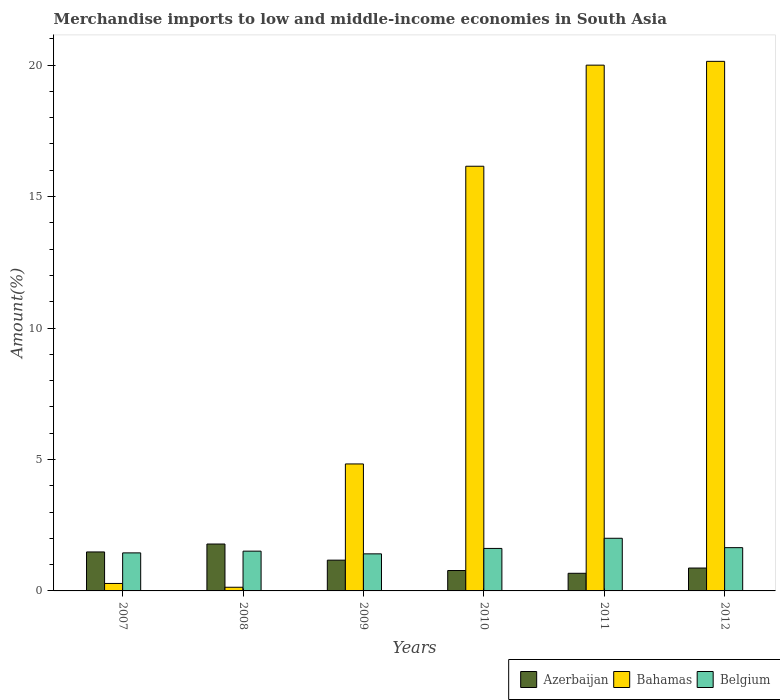How many groups of bars are there?
Offer a terse response. 6. Are the number of bars on each tick of the X-axis equal?
Your answer should be very brief. Yes. How many bars are there on the 4th tick from the left?
Make the answer very short. 3. In how many cases, is the number of bars for a given year not equal to the number of legend labels?
Your answer should be very brief. 0. What is the percentage of amount earned from merchandise imports in Bahamas in 2007?
Give a very brief answer. 0.28. Across all years, what is the maximum percentage of amount earned from merchandise imports in Belgium?
Offer a very short reply. 2. Across all years, what is the minimum percentage of amount earned from merchandise imports in Azerbaijan?
Keep it short and to the point. 0.67. In which year was the percentage of amount earned from merchandise imports in Azerbaijan minimum?
Offer a very short reply. 2011. What is the total percentage of amount earned from merchandise imports in Azerbaijan in the graph?
Your answer should be compact. 6.75. What is the difference between the percentage of amount earned from merchandise imports in Azerbaijan in 2009 and that in 2011?
Provide a succinct answer. 0.5. What is the difference between the percentage of amount earned from merchandise imports in Azerbaijan in 2007 and the percentage of amount earned from merchandise imports in Bahamas in 2010?
Provide a short and direct response. -14.67. What is the average percentage of amount earned from merchandise imports in Bahamas per year?
Keep it short and to the point. 10.26. In the year 2009, what is the difference between the percentage of amount earned from merchandise imports in Belgium and percentage of amount earned from merchandise imports in Bahamas?
Make the answer very short. -3.42. In how many years, is the percentage of amount earned from merchandise imports in Bahamas greater than 11 %?
Offer a terse response. 3. What is the ratio of the percentage of amount earned from merchandise imports in Bahamas in 2009 to that in 2012?
Your response must be concise. 0.24. Is the percentage of amount earned from merchandise imports in Belgium in 2009 less than that in 2010?
Offer a terse response. Yes. What is the difference between the highest and the second highest percentage of amount earned from merchandise imports in Bahamas?
Your response must be concise. 0.14. What is the difference between the highest and the lowest percentage of amount earned from merchandise imports in Azerbaijan?
Ensure brevity in your answer.  1.11. In how many years, is the percentage of amount earned from merchandise imports in Belgium greater than the average percentage of amount earned from merchandise imports in Belgium taken over all years?
Offer a very short reply. 3. Is the sum of the percentage of amount earned from merchandise imports in Bahamas in 2009 and 2012 greater than the maximum percentage of amount earned from merchandise imports in Azerbaijan across all years?
Provide a succinct answer. Yes. What does the 2nd bar from the left in 2010 represents?
Keep it short and to the point. Bahamas. What does the 2nd bar from the right in 2008 represents?
Ensure brevity in your answer.  Bahamas. Is it the case that in every year, the sum of the percentage of amount earned from merchandise imports in Belgium and percentage of amount earned from merchandise imports in Bahamas is greater than the percentage of amount earned from merchandise imports in Azerbaijan?
Keep it short and to the point. No. How many years are there in the graph?
Your answer should be very brief. 6. What is the difference between two consecutive major ticks on the Y-axis?
Your answer should be compact. 5. Are the values on the major ticks of Y-axis written in scientific E-notation?
Provide a succinct answer. No. Does the graph contain any zero values?
Offer a terse response. No. Does the graph contain grids?
Keep it short and to the point. No. Where does the legend appear in the graph?
Offer a terse response. Bottom right. How are the legend labels stacked?
Your answer should be compact. Horizontal. What is the title of the graph?
Offer a very short reply. Merchandise imports to low and middle-income economies in South Asia. Does "Central Europe" appear as one of the legend labels in the graph?
Offer a very short reply. No. What is the label or title of the X-axis?
Your answer should be very brief. Years. What is the label or title of the Y-axis?
Keep it short and to the point. Amount(%). What is the Amount(%) of Azerbaijan in 2007?
Offer a very short reply. 1.48. What is the Amount(%) in Bahamas in 2007?
Provide a succinct answer. 0.28. What is the Amount(%) of Belgium in 2007?
Provide a short and direct response. 1.45. What is the Amount(%) of Azerbaijan in 2008?
Ensure brevity in your answer.  1.78. What is the Amount(%) in Bahamas in 2008?
Your answer should be very brief. 0.14. What is the Amount(%) of Belgium in 2008?
Your response must be concise. 1.51. What is the Amount(%) of Azerbaijan in 2009?
Offer a very short reply. 1.17. What is the Amount(%) of Bahamas in 2009?
Offer a terse response. 4.83. What is the Amount(%) in Belgium in 2009?
Provide a succinct answer. 1.41. What is the Amount(%) of Azerbaijan in 2010?
Ensure brevity in your answer.  0.78. What is the Amount(%) of Bahamas in 2010?
Keep it short and to the point. 16.15. What is the Amount(%) of Belgium in 2010?
Provide a succinct answer. 1.62. What is the Amount(%) of Azerbaijan in 2011?
Your answer should be very brief. 0.67. What is the Amount(%) in Bahamas in 2011?
Your answer should be very brief. 20. What is the Amount(%) in Belgium in 2011?
Offer a very short reply. 2. What is the Amount(%) in Azerbaijan in 2012?
Offer a very short reply. 0.87. What is the Amount(%) in Bahamas in 2012?
Make the answer very short. 20.14. What is the Amount(%) in Belgium in 2012?
Your answer should be compact. 1.65. Across all years, what is the maximum Amount(%) in Azerbaijan?
Keep it short and to the point. 1.78. Across all years, what is the maximum Amount(%) in Bahamas?
Your answer should be compact. 20.14. Across all years, what is the maximum Amount(%) in Belgium?
Ensure brevity in your answer.  2. Across all years, what is the minimum Amount(%) in Azerbaijan?
Make the answer very short. 0.67. Across all years, what is the minimum Amount(%) in Bahamas?
Provide a short and direct response. 0.14. Across all years, what is the minimum Amount(%) in Belgium?
Your answer should be very brief. 1.41. What is the total Amount(%) in Azerbaijan in the graph?
Your answer should be very brief. 6.75. What is the total Amount(%) in Bahamas in the graph?
Give a very brief answer. 61.55. What is the total Amount(%) in Belgium in the graph?
Provide a short and direct response. 9.63. What is the difference between the Amount(%) of Azerbaijan in 2007 and that in 2008?
Your answer should be very brief. -0.3. What is the difference between the Amount(%) in Bahamas in 2007 and that in 2008?
Offer a very short reply. 0.14. What is the difference between the Amount(%) in Belgium in 2007 and that in 2008?
Provide a succinct answer. -0.07. What is the difference between the Amount(%) in Azerbaijan in 2007 and that in 2009?
Ensure brevity in your answer.  0.31. What is the difference between the Amount(%) of Bahamas in 2007 and that in 2009?
Your answer should be very brief. -4.55. What is the difference between the Amount(%) in Belgium in 2007 and that in 2009?
Offer a terse response. 0.04. What is the difference between the Amount(%) of Azerbaijan in 2007 and that in 2010?
Offer a very short reply. 0.71. What is the difference between the Amount(%) of Bahamas in 2007 and that in 2010?
Your response must be concise. -15.87. What is the difference between the Amount(%) of Belgium in 2007 and that in 2010?
Keep it short and to the point. -0.17. What is the difference between the Amount(%) in Azerbaijan in 2007 and that in 2011?
Make the answer very short. 0.81. What is the difference between the Amount(%) in Bahamas in 2007 and that in 2011?
Provide a succinct answer. -19.72. What is the difference between the Amount(%) of Belgium in 2007 and that in 2011?
Offer a very short reply. -0.56. What is the difference between the Amount(%) in Azerbaijan in 2007 and that in 2012?
Ensure brevity in your answer.  0.61. What is the difference between the Amount(%) in Bahamas in 2007 and that in 2012?
Offer a terse response. -19.86. What is the difference between the Amount(%) of Belgium in 2007 and that in 2012?
Provide a succinct answer. -0.2. What is the difference between the Amount(%) of Azerbaijan in 2008 and that in 2009?
Your answer should be very brief. 0.61. What is the difference between the Amount(%) of Bahamas in 2008 and that in 2009?
Offer a terse response. -4.69. What is the difference between the Amount(%) in Belgium in 2008 and that in 2009?
Provide a succinct answer. 0.1. What is the difference between the Amount(%) in Bahamas in 2008 and that in 2010?
Keep it short and to the point. -16.01. What is the difference between the Amount(%) of Belgium in 2008 and that in 2010?
Offer a terse response. -0.1. What is the difference between the Amount(%) in Azerbaijan in 2008 and that in 2011?
Offer a very short reply. 1.11. What is the difference between the Amount(%) of Bahamas in 2008 and that in 2011?
Provide a short and direct response. -19.86. What is the difference between the Amount(%) of Belgium in 2008 and that in 2011?
Provide a succinct answer. -0.49. What is the difference between the Amount(%) of Azerbaijan in 2008 and that in 2012?
Provide a succinct answer. 0.91. What is the difference between the Amount(%) of Bahamas in 2008 and that in 2012?
Your answer should be very brief. -20. What is the difference between the Amount(%) in Belgium in 2008 and that in 2012?
Offer a very short reply. -0.13. What is the difference between the Amount(%) in Azerbaijan in 2009 and that in 2010?
Your answer should be very brief. 0.39. What is the difference between the Amount(%) in Bahamas in 2009 and that in 2010?
Offer a very short reply. -11.32. What is the difference between the Amount(%) in Belgium in 2009 and that in 2010?
Provide a short and direct response. -0.21. What is the difference between the Amount(%) in Azerbaijan in 2009 and that in 2011?
Offer a terse response. 0.5. What is the difference between the Amount(%) of Bahamas in 2009 and that in 2011?
Offer a very short reply. -15.17. What is the difference between the Amount(%) of Belgium in 2009 and that in 2011?
Keep it short and to the point. -0.59. What is the difference between the Amount(%) of Azerbaijan in 2009 and that in 2012?
Keep it short and to the point. 0.3. What is the difference between the Amount(%) of Bahamas in 2009 and that in 2012?
Ensure brevity in your answer.  -15.31. What is the difference between the Amount(%) of Belgium in 2009 and that in 2012?
Keep it short and to the point. -0.24. What is the difference between the Amount(%) in Azerbaijan in 2010 and that in 2011?
Your response must be concise. 0.11. What is the difference between the Amount(%) in Bahamas in 2010 and that in 2011?
Make the answer very short. -3.85. What is the difference between the Amount(%) of Belgium in 2010 and that in 2011?
Offer a very short reply. -0.39. What is the difference between the Amount(%) in Azerbaijan in 2010 and that in 2012?
Keep it short and to the point. -0.09. What is the difference between the Amount(%) in Bahamas in 2010 and that in 2012?
Give a very brief answer. -3.99. What is the difference between the Amount(%) of Belgium in 2010 and that in 2012?
Offer a very short reply. -0.03. What is the difference between the Amount(%) of Azerbaijan in 2011 and that in 2012?
Make the answer very short. -0.2. What is the difference between the Amount(%) in Bahamas in 2011 and that in 2012?
Provide a short and direct response. -0.14. What is the difference between the Amount(%) in Belgium in 2011 and that in 2012?
Keep it short and to the point. 0.36. What is the difference between the Amount(%) of Azerbaijan in 2007 and the Amount(%) of Bahamas in 2008?
Offer a very short reply. 1.34. What is the difference between the Amount(%) of Azerbaijan in 2007 and the Amount(%) of Belgium in 2008?
Make the answer very short. -0.03. What is the difference between the Amount(%) of Bahamas in 2007 and the Amount(%) of Belgium in 2008?
Offer a very short reply. -1.23. What is the difference between the Amount(%) of Azerbaijan in 2007 and the Amount(%) of Bahamas in 2009?
Offer a very short reply. -3.35. What is the difference between the Amount(%) in Azerbaijan in 2007 and the Amount(%) in Belgium in 2009?
Your response must be concise. 0.07. What is the difference between the Amount(%) of Bahamas in 2007 and the Amount(%) of Belgium in 2009?
Offer a very short reply. -1.13. What is the difference between the Amount(%) in Azerbaijan in 2007 and the Amount(%) in Bahamas in 2010?
Offer a very short reply. -14.67. What is the difference between the Amount(%) of Azerbaijan in 2007 and the Amount(%) of Belgium in 2010?
Ensure brevity in your answer.  -0.13. What is the difference between the Amount(%) in Bahamas in 2007 and the Amount(%) in Belgium in 2010?
Give a very brief answer. -1.33. What is the difference between the Amount(%) of Azerbaijan in 2007 and the Amount(%) of Bahamas in 2011?
Ensure brevity in your answer.  -18.52. What is the difference between the Amount(%) of Azerbaijan in 2007 and the Amount(%) of Belgium in 2011?
Give a very brief answer. -0.52. What is the difference between the Amount(%) of Bahamas in 2007 and the Amount(%) of Belgium in 2011?
Provide a short and direct response. -1.72. What is the difference between the Amount(%) in Azerbaijan in 2007 and the Amount(%) in Bahamas in 2012?
Your answer should be compact. -18.66. What is the difference between the Amount(%) of Azerbaijan in 2007 and the Amount(%) of Belgium in 2012?
Your answer should be very brief. -0.16. What is the difference between the Amount(%) in Bahamas in 2007 and the Amount(%) in Belgium in 2012?
Give a very brief answer. -1.36. What is the difference between the Amount(%) in Azerbaijan in 2008 and the Amount(%) in Bahamas in 2009?
Offer a very short reply. -3.05. What is the difference between the Amount(%) of Azerbaijan in 2008 and the Amount(%) of Belgium in 2009?
Keep it short and to the point. 0.37. What is the difference between the Amount(%) of Bahamas in 2008 and the Amount(%) of Belgium in 2009?
Provide a short and direct response. -1.27. What is the difference between the Amount(%) in Azerbaijan in 2008 and the Amount(%) in Bahamas in 2010?
Give a very brief answer. -14.37. What is the difference between the Amount(%) of Azerbaijan in 2008 and the Amount(%) of Belgium in 2010?
Offer a terse response. 0.17. What is the difference between the Amount(%) of Bahamas in 2008 and the Amount(%) of Belgium in 2010?
Keep it short and to the point. -1.48. What is the difference between the Amount(%) in Azerbaijan in 2008 and the Amount(%) in Bahamas in 2011?
Provide a succinct answer. -18.22. What is the difference between the Amount(%) of Azerbaijan in 2008 and the Amount(%) of Belgium in 2011?
Offer a very short reply. -0.22. What is the difference between the Amount(%) of Bahamas in 2008 and the Amount(%) of Belgium in 2011?
Keep it short and to the point. -1.86. What is the difference between the Amount(%) in Azerbaijan in 2008 and the Amount(%) in Bahamas in 2012?
Your answer should be compact. -18.36. What is the difference between the Amount(%) in Azerbaijan in 2008 and the Amount(%) in Belgium in 2012?
Offer a very short reply. 0.14. What is the difference between the Amount(%) in Bahamas in 2008 and the Amount(%) in Belgium in 2012?
Keep it short and to the point. -1.51. What is the difference between the Amount(%) in Azerbaijan in 2009 and the Amount(%) in Bahamas in 2010?
Make the answer very short. -14.98. What is the difference between the Amount(%) of Azerbaijan in 2009 and the Amount(%) of Belgium in 2010?
Your answer should be compact. -0.45. What is the difference between the Amount(%) of Bahamas in 2009 and the Amount(%) of Belgium in 2010?
Your response must be concise. 3.21. What is the difference between the Amount(%) of Azerbaijan in 2009 and the Amount(%) of Bahamas in 2011?
Your answer should be compact. -18.83. What is the difference between the Amount(%) of Azerbaijan in 2009 and the Amount(%) of Belgium in 2011?
Give a very brief answer. -0.83. What is the difference between the Amount(%) in Bahamas in 2009 and the Amount(%) in Belgium in 2011?
Provide a succinct answer. 2.83. What is the difference between the Amount(%) of Azerbaijan in 2009 and the Amount(%) of Bahamas in 2012?
Provide a short and direct response. -18.97. What is the difference between the Amount(%) of Azerbaijan in 2009 and the Amount(%) of Belgium in 2012?
Provide a succinct answer. -0.48. What is the difference between the Amount(%) of Bahamas in 2009 and the Amount(%) of Belgium in 2012?
Your response must be concise. 3.18. What is the difference between the Amount(%) in Azerbaijan in 2010 and the Amount(%) in Bahamas in 2011?
Give a very brief answer. -19.22. What is the difference between the Amount(%) of Azerbaijan in 2010 and the Amount(%) of Belgium in 2011?
Your response must be concise. -1.23. What is the difference between the Amount(%) of Bahamas in 2010 and the Amount(%) of Belgium in 2011?
Your response must be concise. 14.15. What is the difference between the Amount(%) of Azerbaijan in 2010 and the Amount(%) of Bahamas in 2012?
Your answer should be very brief. -19.37. What is the difference between the Amount(%) of Azerbaijan in 2010 and the Amount(%) of Belgium in 2012?
Your answer should be very brief. -0.87. What is the difference between the Amount(%) in Bahamas in 2010 and the Amount(%) in Belgium in 2012?
Offer a very short reply. 14.51. What is the difference between the Amount(%) in Azerbaijan in 2011 and the Amount(%) in Bahamas in 2012?
Your response must be concise. -19.47. What is the difference between the Amount(%) of Azerbaijan in 2011 and the Amount(%) of Belgium in 2012?
Offer a very short reply. -0.98. What is the difference between the Amount(%) of Bahamas in 2011 and the Amount(%) of Belgium in 2012?
Your response must be concise. 18.35. What is the average Amount(%) in Azerbaijan per year?
Your answer should be very brief. 1.13. What is the average Amount(%) in Bahamas per year?
Keep it short and to the point. 10.26. What is the average Amount(%) of Belgium per year?
Keep it short and to the point. 1.61. In the year 2007, what is the difference between the Amount(%) in Azerbaijan and Amount(%) in Bahamas?
Provide a succinct answer. 1.2. In the year 2007, what is the difference between the Amount(%) of Azerbaijan and Amount(%) of Belgium?
Keep it short and to the point. 0.04. In the year 2007, what is the difference between the Amount(%) in Bahamas and Amount(%) in Belgium?
Give a very brief answer. -1.16. In the year 2008, what is the difference between the Amount(%) in Azerbaijan and Amount(%) in Bahamas?
Keep it short and to the point. 1.64. In the year 2008, what is the difference between the Amount(%) in Azerbaijan and Amount(%) in Belgium?
Your response must be concise. 0.27. In the year 2008, what is the difference between the Amount(%) in Bahamas and Amount(%) in Belgium?
Provide a succinct answer. -1.37. In the year 2009, what is the difference between the Amount(%) of Azerbaijan and Amount(%) of Bahamas?
Ensure brevity in your answer.  -3.66. In the year 2009, what is the difference between the Amount(%) in Azerbaijan and Amount(%) in Belgium?
Offer a very short reply. -0.24. In the year 2009, what is the difference between the Amount(%) in Bahamas and Amount(%) in Belgium?
Provide a short and direct response. 3.42. In the year 2010, what is the difference between the Amount(%) of Azerbaijan and Amount(%) of Bahamas?
Offer a very short reply. -15.38. In the year 2010, what is the difference between the Amount(%) of Azerbaijan and Amount(%) of Belgium?
Provide a short and direct response. -0.84. In the year 2010, what is the difference between the Amount(%) in Bahamas and Amount(%) in Belgium?
Keep it short and to the point. 14.54. In the year 2011, what is the difference between the Amount(%) in Azerbaijan and Amount(%) in Bahamas?
Your answer should be very brief. -19.33. In the year 2011, what is the difference between the Amount(%) of Azerbaijan and Amount(%) of Belgium?
Offer a very short reply. -1.33. In the year 2011, what is the difference between the Amount(%) in Bahamas and Amount(%) in Belgium?
Your answer should be compact. 18. In the year 2012, what is the difference between the Amount(%) of Azerbaijan and Amount(%) of Bahamas?
Your answer should be very brief. -19.27. In the year 2012, what is the difference between the Amount(%) in Azerbaijan and Amount(%) in Belgium?
Provide a succinct answer. -0.78. In the year 2012, what is the difference between the Amount(%) in Bahamas and Amount(%) in Belgium?
Provide a succinct answer. 18.5. What is the ratio of the Amount(%) in Azerbaijan in 2007 to that in 2008?
Your response must be concise. 0.83. What is the ratio of the Amount(%) in Bahamas in 2007 to that in 2008?
Offer a terse response. 2.03. What is the ratio of the Amount(%) in Belgium in 2007 to that in 2008?
Provide a short and direct response. 0.96. What is the ratio of the Amount(%) in Azerbaijan in 2007 to that in 2009?
Your answer should be compact. 1.27. What is the ratio of the Amount(%) of Bahamas in 2007 to that in 2009?
Offer a terse response. 0.06. What is the ratio of the Amount(%) in Belgium in 2007 to that in 2009?
Offer a very short reply. 1.03. What is the ratio of the Amount(%) in Azerbaijan in 2007 to that in 2010?
Give a very brief answer. 1.91. What is the ratio of the Amount(%) in Bahamas in 2007 to that in 2010?
Your answer should be compact. 0.02. What is the ratio of the Amount(%) in Belgium in 2007 to that in 2010?
Give a very brief answer. 0.9. What is the ratio of the Amount(%) of Azerbaijan in 2007 to that in 2011?
Your answer should be very brief. 2.21. What is the ratio of the Amount(%) in Bahamas in 2007 to that in 2011?
Your response must be concise. 0.01. What is the ratio of the Amount(%) of Belgium in 2007 to that in 2011?
Your response must be concise. 0.72. What is the ratio of the Amount(%) of Azerbaijan in 2007 to that in 2012?
Offer a very short reply. 1.7. What is the ratio of the Amount(%) of Bahamas in 2007 to that in 2012?
Offer a terse response. 0.01. What is the ratio of the Amount(%) in Belgium in 2007 to that in 2012?
Ensure brevity in your answer.  0.88. What is the ratio of the Amount(%) of Azerbaijan in 2008 to that in 2009?
Keep it short and to the point. 1.52. What is the ratio of the Amount(%) of Bahamas in 2008 to that in 2009?
Offer a very short reply. 0.03. What is the ratio of the Amount(%) of Belgium in 2008 to that in 2009?
Provide a succinct answer. 1.07. What is the ratio of the Amount(%) of Azerbaijan in 2008 to that in 2010?
Offer a terse response. 2.3. What is the ratio of the Amount(%) of Bahamas in 2008 to that in 2010?
Provide a succinct answer. 0.01. What is the ratio of the Amount(%) in Belgium in 2008 to that in 2010?
Keep it short and to the point. 0.94. What is the ratio of the Amount(%) of Azerbaijan in 2008 to that in 2011?
Make the answer very short. 2.66. What is the ratio of the Amount(%) of Bahamas in 2008 to that in 2011?
Your response must be concise. 0.01. What is the ratio of the Amount(%) of Belgium in 2008 to that in 2011?
Your response must be concise. 0.76. What is the ratio of the Amount(%) in Azerbaijan in 2008 to that in 2012?
Provide a succinct answer. 2.05. What is the ratio of the Amount(%) of Bahamas in 2008 to that in 2012?
Your answer should be very brief. 0.01. What is the ratio of the Amount(%) in Belgium in 2008 to that in 2012?
Your answer should be very brief. 0.92. What is the ratio of the Amount(%) of Azerbaijan in 2009 to that in 2010?
Keep it short and to the point. 1.51. What is the ratio of the Amount(%) in Bahamas in 2009 to that in 2010?
Your response must be concise. 0.3. What is the ratio of the Amount(%) in Belgium in 2009 to that in 2010?
Your response must be concise. 0.87. What is the ratio of the Amount(%) in Azerbaijan in 2009 to that in 2011?
Make the answer very short. 1.75. What is the ratio of the Amount(%) of Bahamas in 2009 to that in 2011?
Provide a succinct answer. 0.24. What is the ratio of the Amount(%) in Belgium in 2009 to that in 2011?
Offer a terse response. 0.7. What is the ratio of the Amount(%) in Azerbaijan in 2009 to that in 2012?
Keep it short and to the point. 1.34. What is the ratio of the Amount(%) of Bahamas in 2009 to that in 2012?
Make the answer very short. 0.24. What is the ratio of the Amount(%) of Belgium in 2009 to that in 2012?
Offer a very short reply. 0.86. What is the ratio of the Amount(%) of Azerbaijan in 2010 to that in 2011?
Your response must be concise. 1.16. What is the ratio of the Amount(%) in Bahamas in 2010 to that in 2011?
Keep it short and to the point. 0.81. What is the ratio of the Amount(%) in Belgium in 2010 to that in 2011?
Your answer should be very brief. 0.81. What is the ratio of the Amount(%) in Azerbaijan in 2010 to that in 2012?
Your answer should be very brief. 0.89. What is the ratio of the Amount(%) of Bahamas in 2010 to that in 2012?
Your answer should be compact. 0.8. What is the ratio of the Amount(%) in Belgium in 2010 to that in 2012?
Offer a terse response. 0.98. What is the ratio of the Amount(%) in Azerbaijan in 2011 to that in 2012?
Ensure brevity in your answer.  0.77. What is the ratio of the Amount(%) in Belgium in 2011 to that in 2012?
Your response must be concise. 1.22. What is the difference between the highest and the second highest Amount(%) in Azerbaijan?
Make the answer very short. 0.3. What is the difference between the highest and the second highest Amount(%) in Bahamas?
Provide a short and direct response. 0.14. What is the difference between the highest and the second highest Amount(%) of Belgium?
Give a very brief answer. 0.36. What is the difference between the highest and the lowest Amount(%) of Azerbaijan?
Provide a succinct answer. 1.11. What is the difference between the highest and the lowest Amount(%) of Bahamas?
Provide a short and direct response. 20. What is the difference between the highest and the lowest Amount(%) of Belgium?
Make the answer very short. 0.59. 